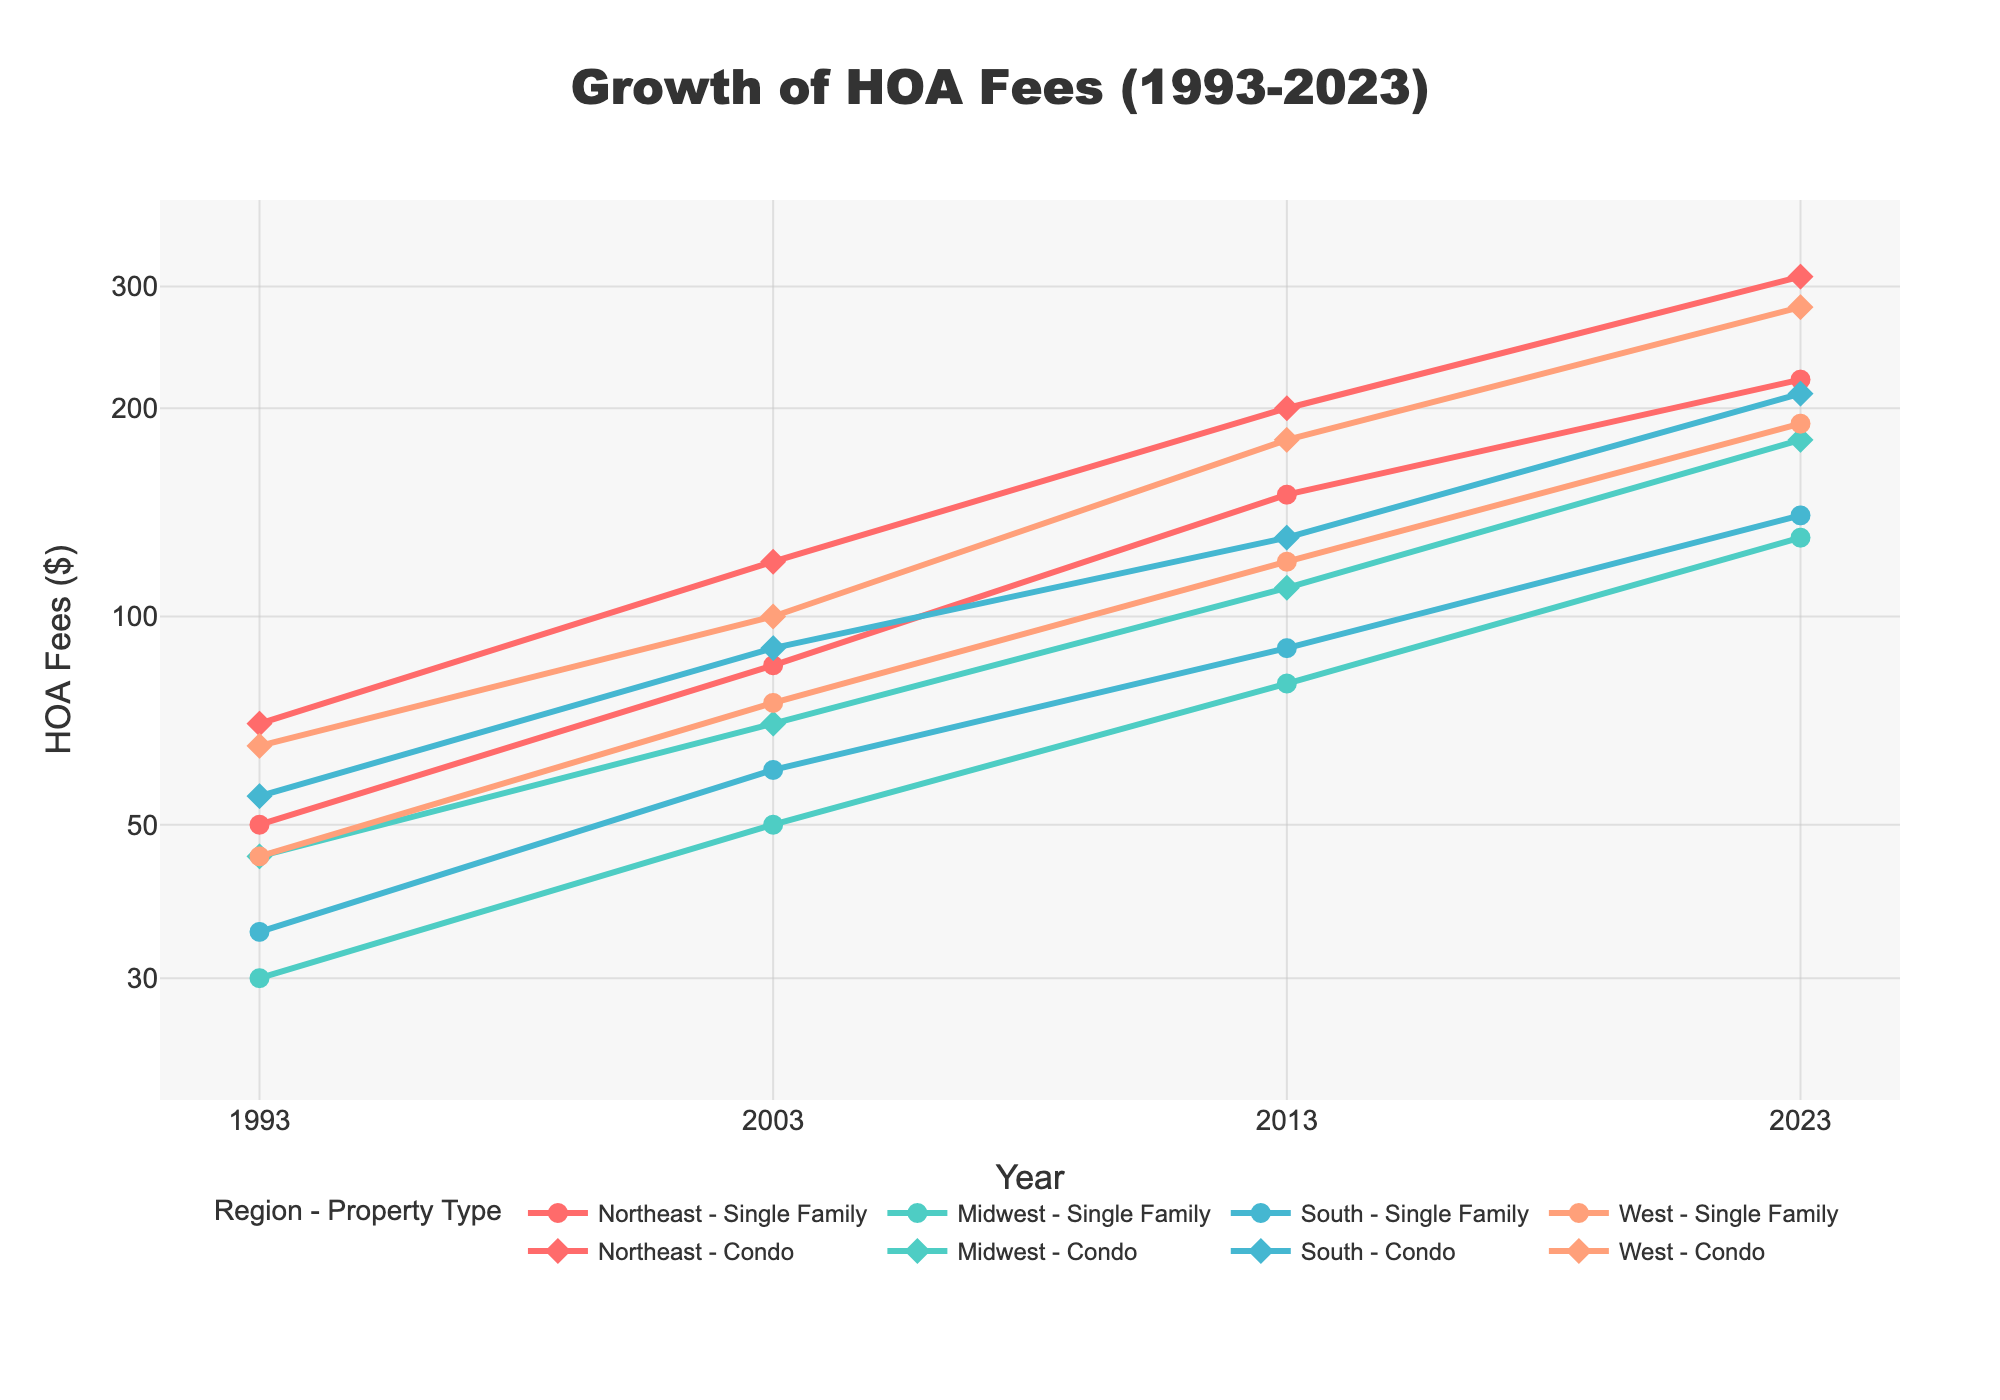What is the title of the line plot? The title is displayed prominently at the top of the plot. It reads "Growth of HOA Fees (1993-2023)".
Answer: Growth of HOA Fees (1993-2023) Which region shows the highest HOA fees for condos in 2023? Locate the marks for the year 2023 on the x-axis and find the highest point among those labeled with condo. The West region has the highest fees at $280.
Answer: West What is the range of the y-axis values? The y-axis is on a log scale and ranges from approximately $30 to $300. This is evident from the tick values labeled on the axis.
Answer: $30 to $300 In which year do the Northeast condos surpass $100 in HOA fees? Follow the Northeast condo line and identify the year where the trace crosses the $100 mark on the y-axis. This happens around 2003.
Answer: 2003 How much did the HOA fees for Midwest single-family homes increase from 1993 to 2023? Identify the values for Midwest single-family homes in 1993 and 2023 from the plot. The values are $30 in 1993 and $130 in 2023. Subtract 30 from 130 to get the increase.
Answer: $100 Which property type in the South had a higher HOA fee in 2013, single-family or condo? At the year 2013, compare the y-values of South single-family and condo property types. Condo has a higher fee at $130 compared to single-family at $90.
Answer: Condo By how much did the HOA fees for Northeast single-family homes increase between 2003 and 2013? Locate the y-values for Northeast single-family homes for 2003 and 2013. The values are $85 and $150, respectively. Subtract the 2003 value from the 2013 value.
Answer: $65 What is the average HOA fee for Midwest condos over the years provided? Add up the HOA fees for Midwest condos for all the given years (45, 70, 110, 180) and divide by the number of years (4). The calculation is (45 + 70 + 110 + 180) / 4 = 101.25.
Answer: $101.25 Which property type experienced the most significant relative increase in HOA fees in the West region from 1993 to 2023? Calculate the rate of increase for both property types in the West by using the formula (Fee2023 - Fee1993) / Fee1993. For condos: (280 - 65) / 65 ≈ 3.31. For single-family: (190 - 45) / 45 ≈ 3.22. Condos have a slightly higher relative increase.
Answer: Condo Do HOA fees show a pattern in growth across all regions from 1993 to 2023? By examining the overall trend in each region and property type, it is noticeable that there is a consistent upward trend in HOA fees across all regions from 1993 to 2023.
Answer: Yes 